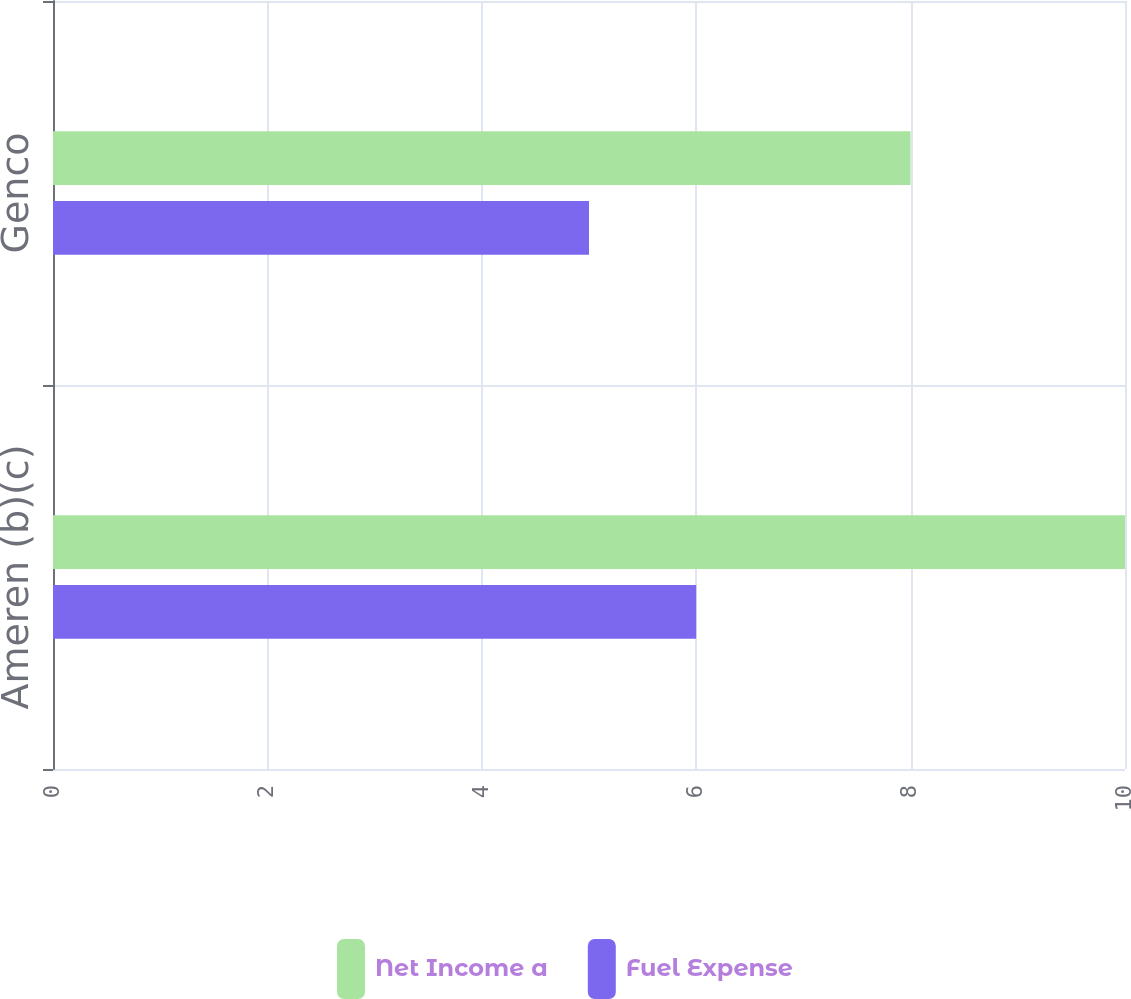Convert chart. <chart><loc_0><loc_0><loc_500><loc_500><stacked_bar_chart><ecel><fcel>Ameren (b)(c)<fcel>Genco<nl><fcel>Net Income a<fcel>10<fcel>8<nl><fcel>Fuel Expense<fcel>6<fcel>5<nl></chart> 